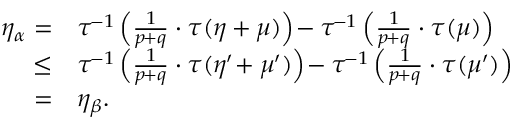<formula> <loc_0><loc_0><loc_500><loc_500>\begin{array} { r l } { \eta _ { \alpha } = } & { \tau ^ { \, - 1 } \left ( \frac { 1 } { p \, + q } \cdot \tau ( \eta + \mu ) \right ) \, - \tau ^ { \, - 1 } \left ( \frac { 1 } { p \, + q } \cdot \tau ( \mu ) \right ) } \\ { \leq } & { \tau ^ { \, - 1 } \left ( \frac { 1 } { p \, + q } \cdot \tau ( \eta ^ { \prime } \, + \mu ^ { \prime } ) \right ) \, - \tau ^ { \, - 1 } \left ( \frac { 1 } { p \, + q } \cdot \tau ( \mu ^ { \prime } ) \right ) } \\ { = } & { \eta _ { \beta } . } \end{array}</formula> 